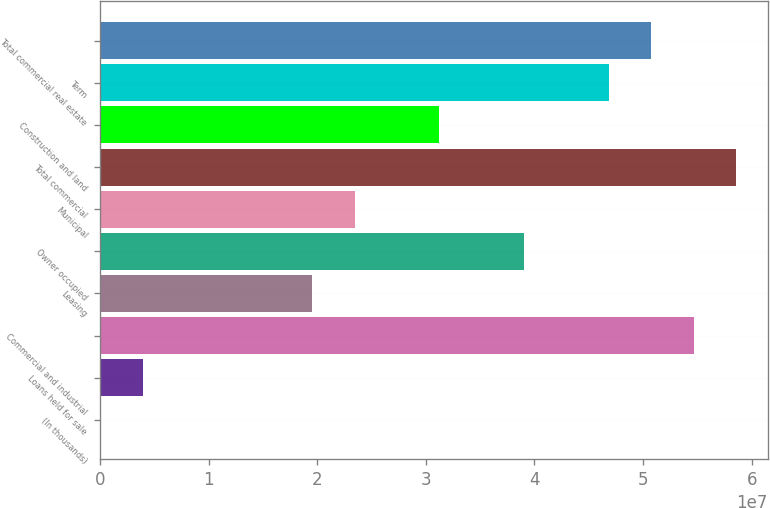Convert chart. <chart><loc_0><loc_0><loc_500><loc_500><bar_chart><fcel>(In thousands)<fcel>Loans held for sale<fcel>Commercial and industrial<fcel>Leasing<fcel>Owner occupied<fcel>Municipal<fcel>Total commercial<fcel>Construction and land<fcel>Term<fcel>Total commercial real estate<nl><fcel>2013<fcel>3.90615e+06<fcel>5.46599e+07<fcel>1.95227e+07<fcel>3.90434e+07<fcel>2.34268e+07<fcel>5.8564e+07<fcel>3.12351e+07<fcel>4.68516e+07<fcel>5.07558e+07<nl></chart> 